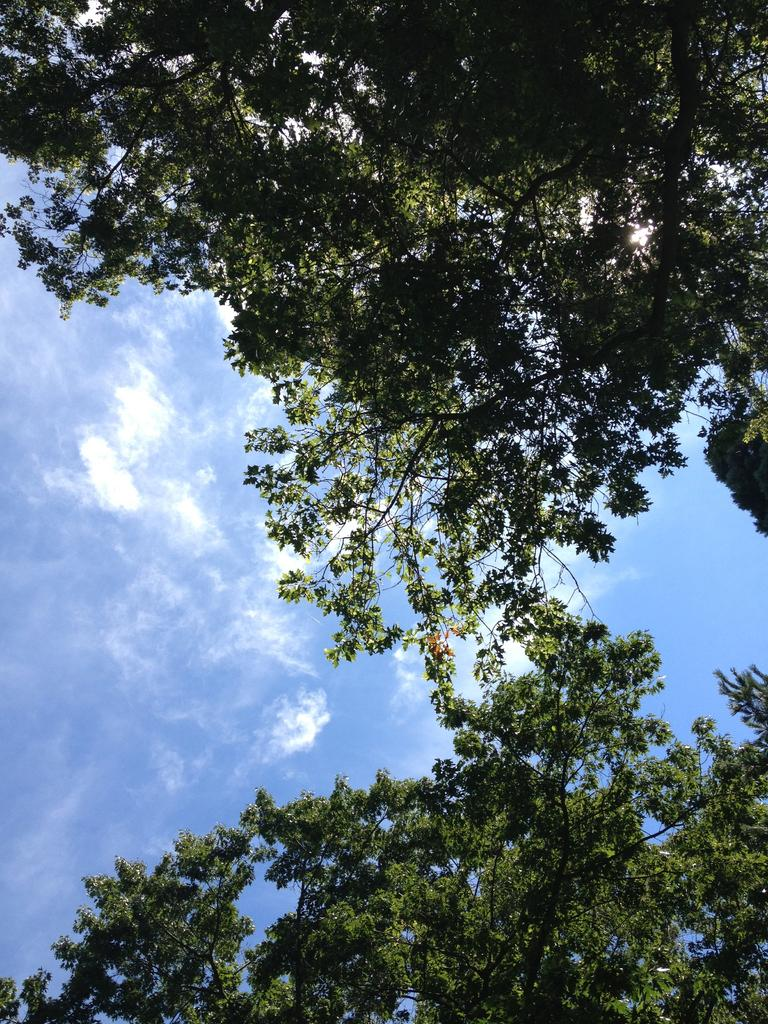What type of vegetation can be seen in the image? There are trees in the image. What can be seen in the sky in the image? There are clouds visible in the sky in the image. Where is the rabbit located in the image? There is no rabbit present in the image. What type of design can be seen on the hydrant in the image? There is no hydrant present in the image. 